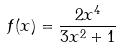Convert formula to latex. <formula><loc_0><loc_0><loc_500><loc_500>f ( x ) = \frac { 2 x ^ { 4 } } { 3 x ^ { 2 } + 1 }</formula> 